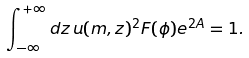Convert formula to latex. <formula><loc_0><loc_0><loc_500><loc_500>\int _ { - \infty } ^ { + \infty } d z \, u ( m , z ) ^ { 2 } F ( \phi ) e ^ { 2 A } = 1 .</formula> 